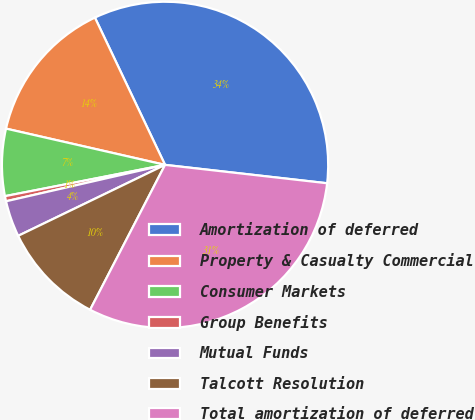Convert chart to OTSL. <chart><loc_0><loc_0><loc_500><loc_500><pie_chart><fcel>Amortization of deferred<fcel>Property & Casualty Commercial<fcel>Consumer Markets<fcel>Group Benefits<fcel>Mutual Funds<fcel>Talcott Resolution<fcel>Total amortization of deferred<nl><fcel>33.87%<fcel>14.36%<fcel>6.64%<fcel>0.51%<fcel>3.58%<fcel>10.24%<fcel>30.8%<nl></chart> 